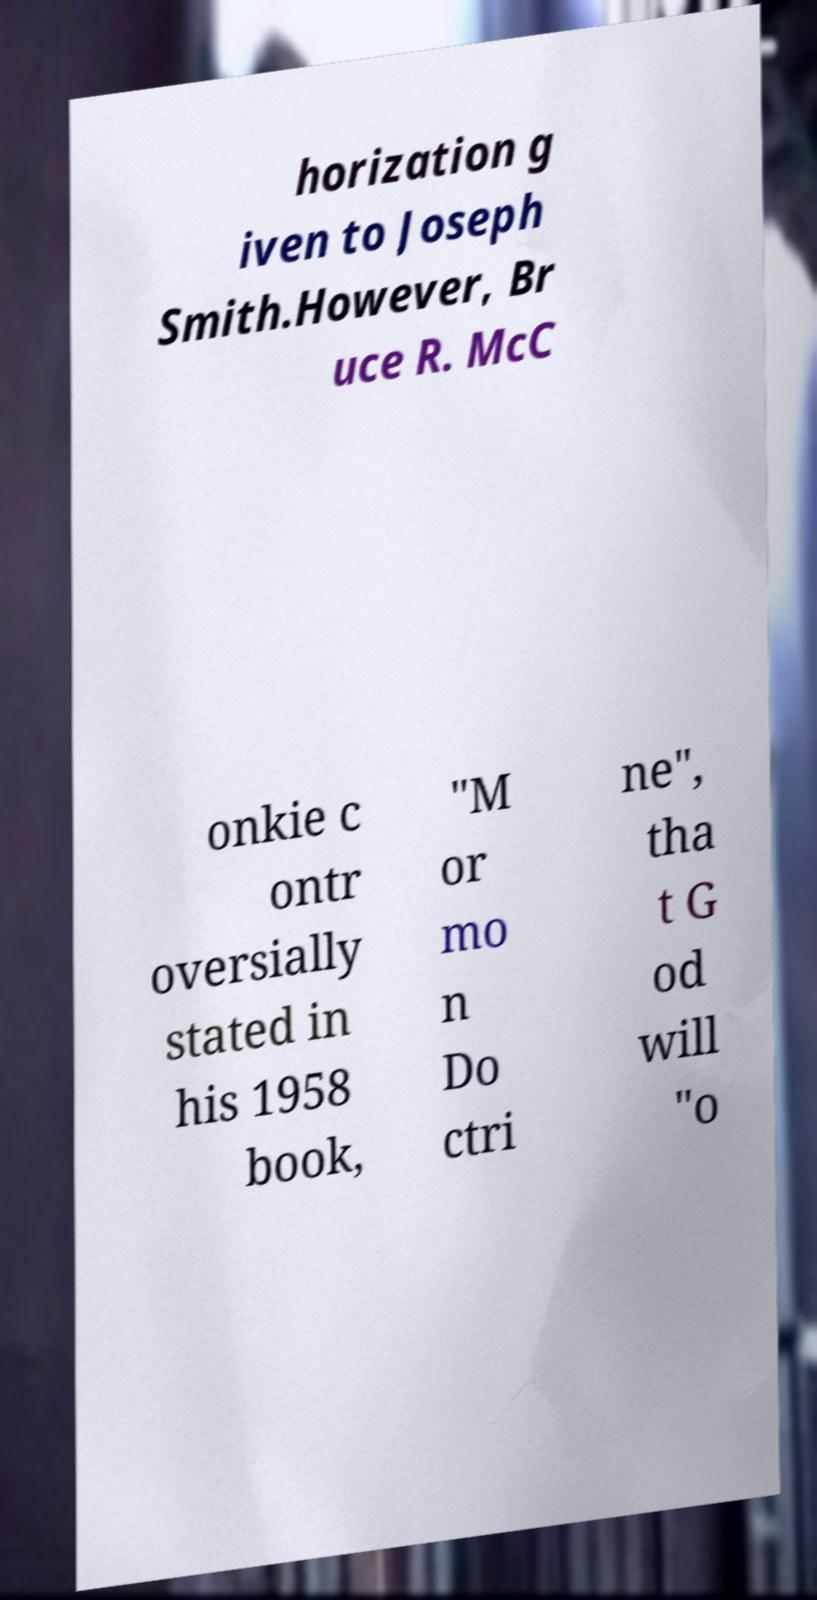Can you read and provide the text displayed in the image?This photo seems to have some interesting text. Can you extract and type it out for me? horization g iven to Joseph Smith.However, Br uce R. McC onkie c ontr oversially stated in his 1958 book, "M or mo n Do ctri ne", tha t G od will "o 